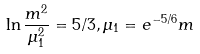<formula> <loc_0><loc_0><loc_500><loc_500>\ln \frac { m ^ { 2 } } { \mu _ { 1 } ^ { 2 } } = 5 / 3 , \mu _ { 1 } = e ^ { - 5 / 6 } m</formula> 